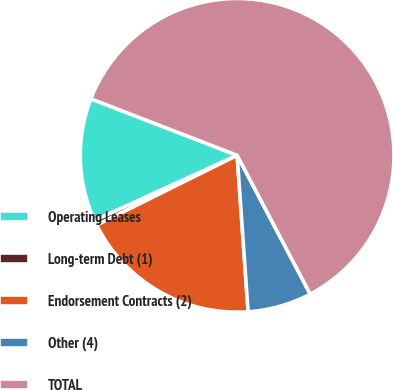Convert chart to OTSL. <chart><loc_0><loc_0><loc_500><loc_500><pie_chart><fcel>Operating Leases<fcel>Long-term Debt (1)<fcel>Endorsement Contracts (2)<fcel>Other (4)<fcel>TOTAL<nl><fcel>12.69%<fcel>0.51%<fcel>18.78%<fcel>6.6%<fcel>61.41%<nl></chart> 